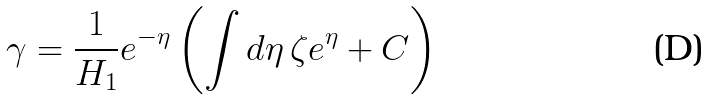<formula> <loc_0><loc_0><loc_500><loc_500>\gamma = \frac { 1 } { H _ { 1 } } e ^ { - \eta } \left ( \int d \eta \, \zeta e ^ { \eta } + C \right )</formula> 